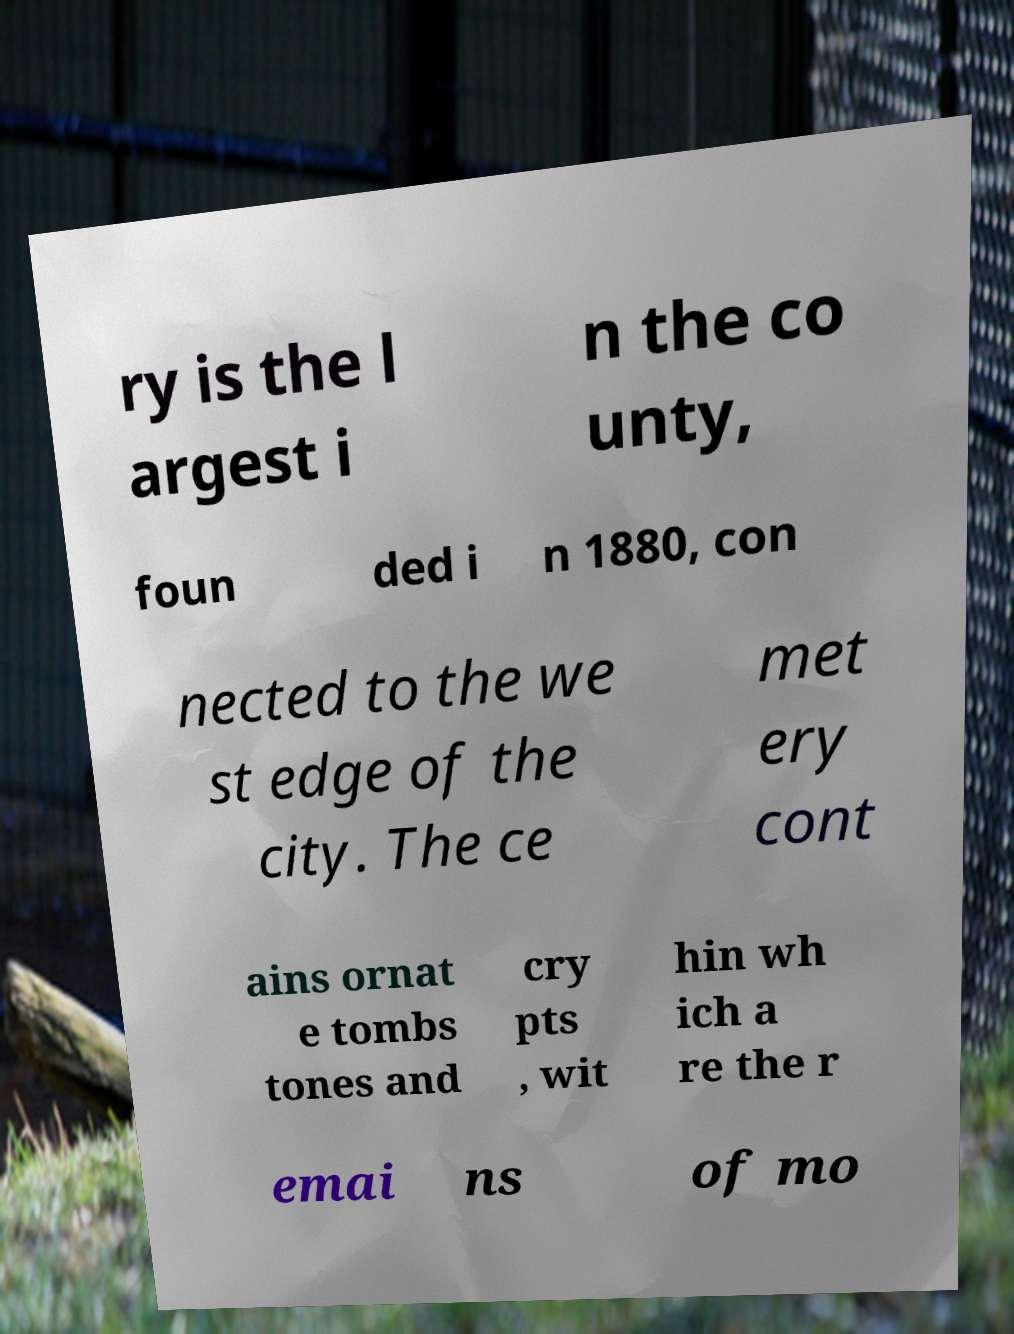Could you assist in decoding the text presented in this image and type it out clearly? ry is the l argest i n the co unty, foun ded i n 1880, con nected to the we st edge of the city. The ce met ery cont ains ornat e tombs tones and cry pts , wit hin wh ich a re the r emai ns of mo 